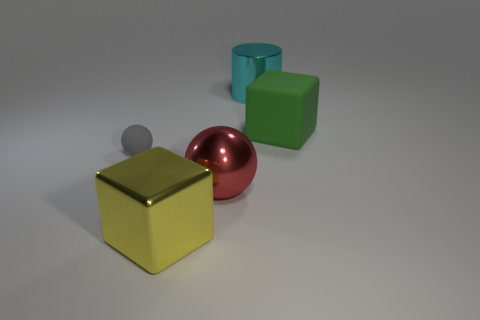Add 1 matte balls. How many objects exist? 6 Subtract all blocks. How many objects are left? 3 Add 4 matte objects. How many matte objects are left? 6 Add 2 gray things. How many gray things exist? 3 Subtract 0 gray cylinders. How many objects are left? 5 Subtract all big yellow metal objects. Subtract all rubber spheres. How many objects are left? 3 